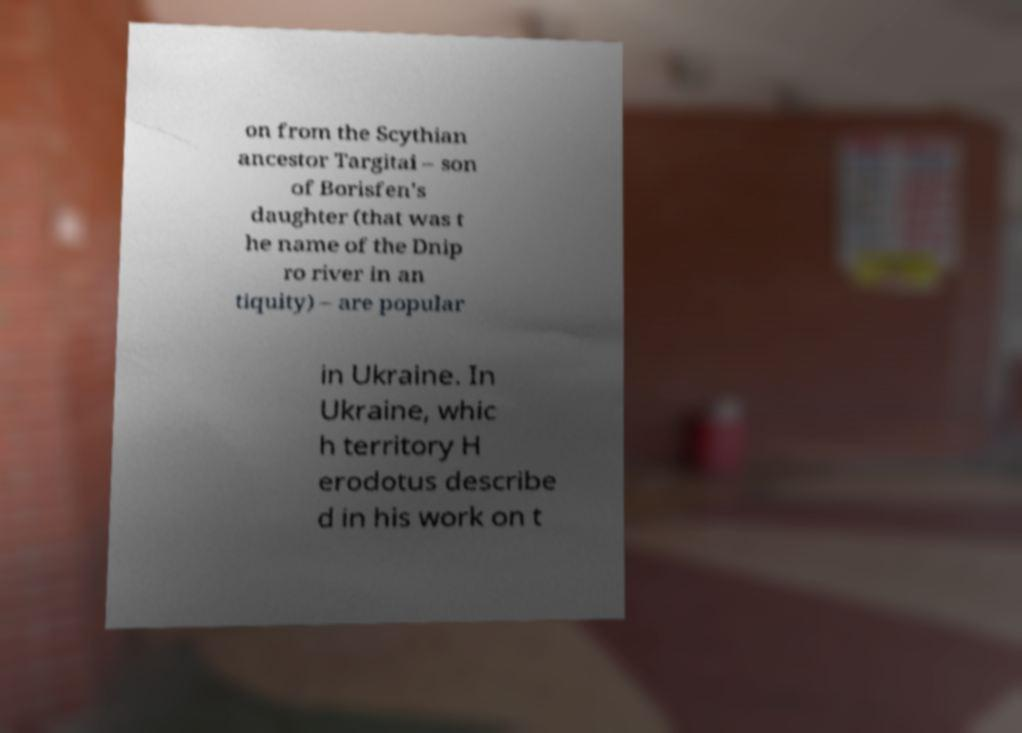Can you read and provide the text displayed in the image?This photo seems to have some interesting text. Can you extract and type it out for me? on from the Scythian ancestor Targitai – son of Borisfen's daughter (that was t he name of the Dnip ro river in an tiquity) – are popular in Ukraine. In Ukraine, whic h territory H erodotus describe d in his work on t 